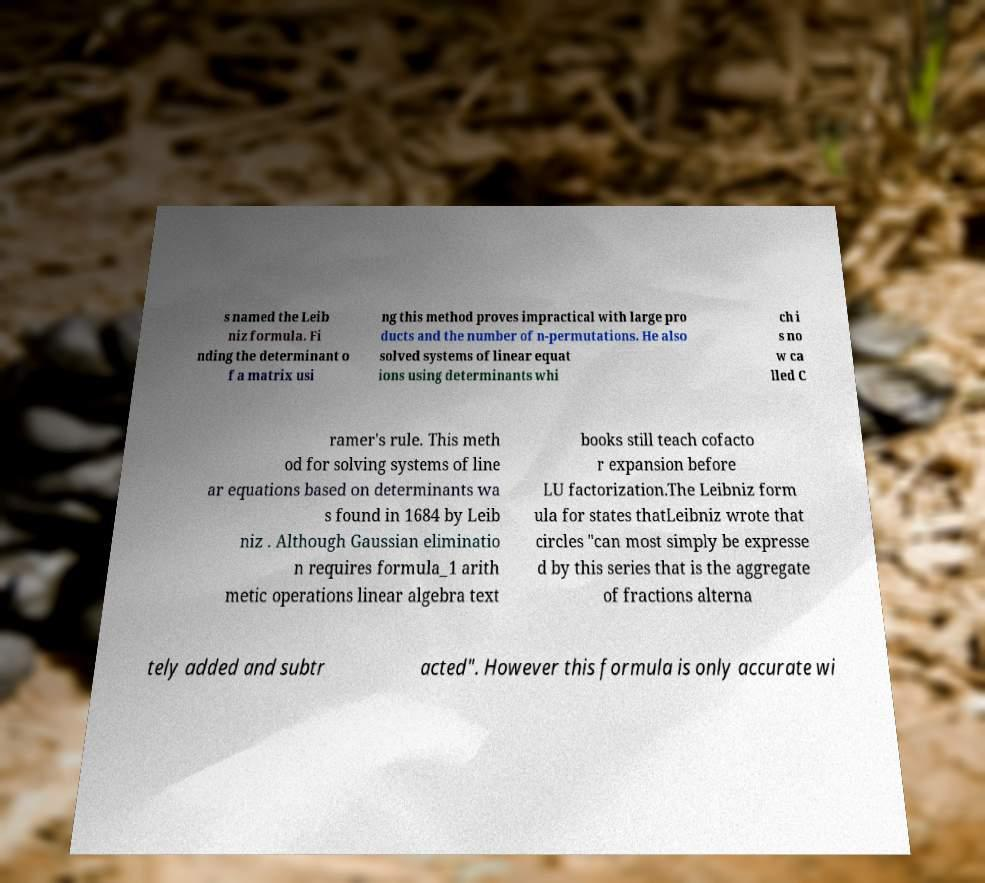Can you accurately transcribe the text from the provided image for me? s named the Leib niz formula. Fi nding the determinant o f a matrix usi ng this method proves impractical with large pro ducts and the number of n-permutations. He also solved systems of linear equat ions using determinants whi ch i s no w ca lled C ramer's rule. This meth od for solving systems of line ar equations based on determinants wa s found in 1684 by Leib niz . Although Gaussian eliminatio n requires formula_1 arith metic operations linear algebra text books still teach cofacto r expansion before LU factorization.The Leibniz form ula for states thatLeibniz wrote that circles "can most simply be expresse d by this series that is the aggregate of fractions alterna tely added and subtr acted". However this formula is only accurate wi 